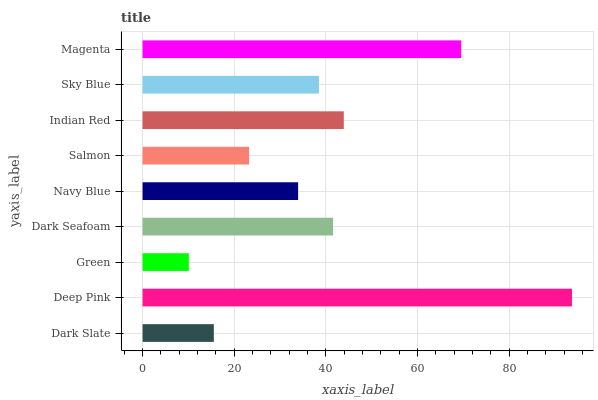Is Green the minimum?
Answer yes or no. Yes. Is Deep Pink the maximum?
Answer yes or no. Yes. Is Deep Pink the minimum?
Answer yes or no. No. Is Green the maximum?
Answer yes or no. No. Is Deep Pink greater than Green?
Answer yes or no. Yes. Is Green less than Deep Pink?
Answer yes or no. Yes. Is Green greater than Deep Pink?
Answer yes or no. No. Is Deep Pink less than Green?
Answer yes or no. No. Is Sky Blue the high median?
Answer yes or no. Yes. Is Sky Blue the low median?
Answer yes or no. Yes. Is Green the high median?
Answer yes or no. No. Is Indian Red the low median?
Answer yes or no. No. 